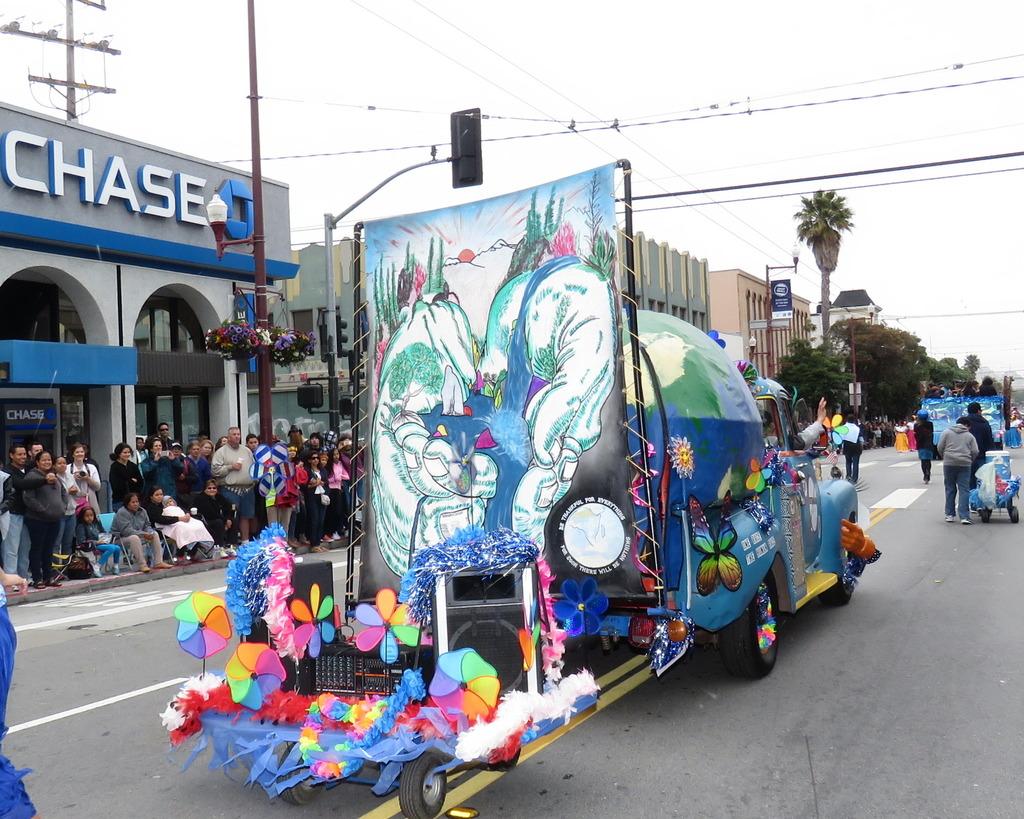What bank is in the left background?
Provide a succinct answer. Chase. 